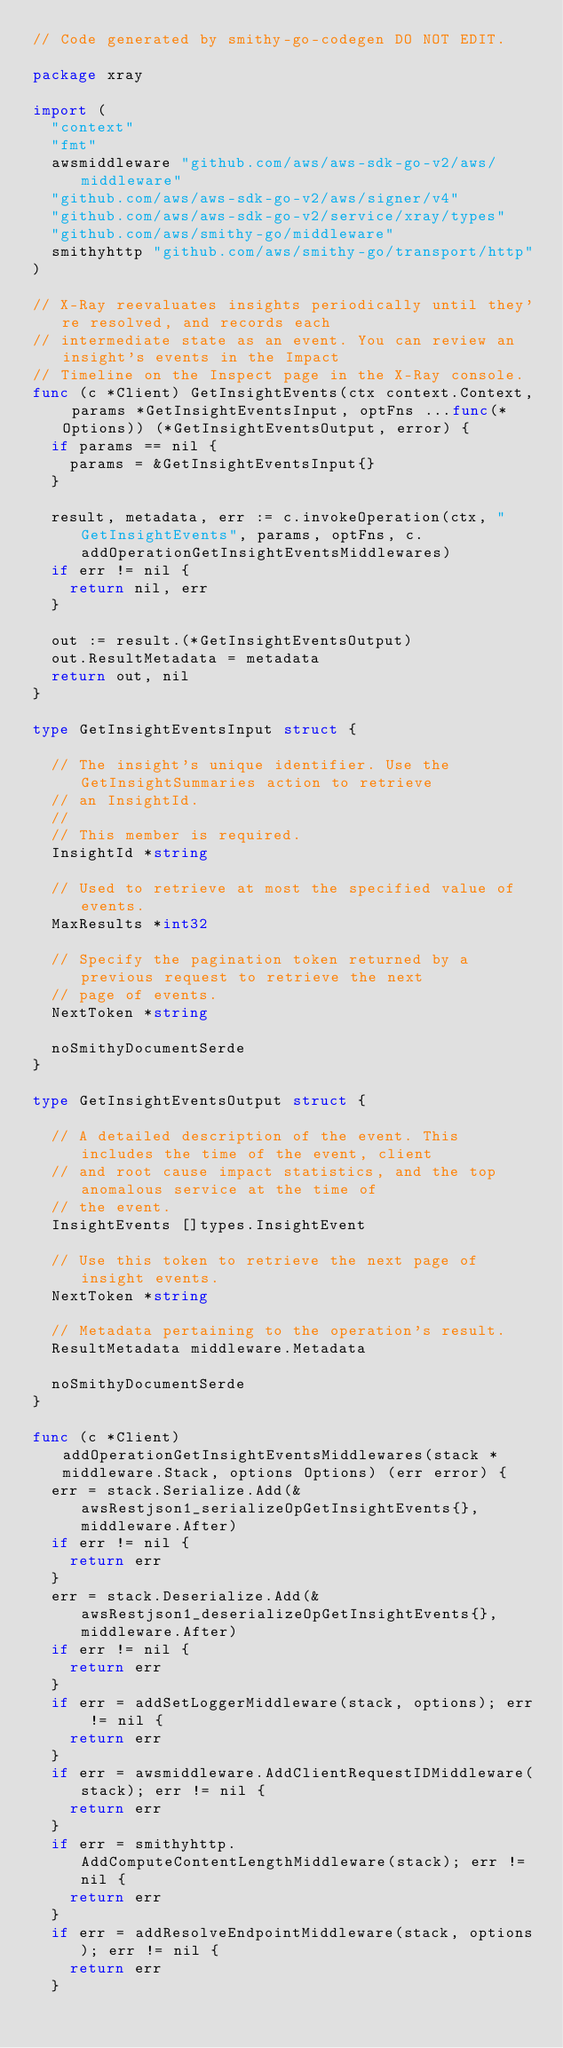Convert code to text. <code><loc_0><loc_0><loc_500><loc_500><_Go_>// Code generated by smithy-go-codegen DO NOT EDIT.

package xray

import (
	"context"
	"fmt"
	awsmiddleware "github.com/aws/aws-sdk-go-v2/aws/middleware"
	"github.com/aws/aws-sdk-go-v2/aws/signer/v4"
	"github.com/aws/aws-sdk-go-v2/service/xray/types"
	"github.com/aws/smithy-go/middleware"
	smithyhttp "github.com/aws/smithy-go/transport/http"
)

// X-Ray reevaluates insights periodically until they're resolved, and records each
// intermediate state as an event. You can review an insight's events in the Impact
// Timeline on the Inspect page in the X-Ray console.
func (c *Client) GetInsightEvents(ctx context.Context, params *GetInsightEventsInput, optFns ...func(*Options)) (*GetInsightEventsOutput, error) {
	if params == nil {
		params = &GetInsightEventsInput{}
	}

	result, metadata, err := c.invokeOperation(ctx, "GetInsightEvents", params, optFns, c.addOperationGetInsightEventsMiddlewares)
	if err != nil {
		return nil, err
	}

	out := result.(*GetInsightEventsOutput)
	out.ResultMetadata = metadata
	return out, nil
}

type GetInsightEventsInput struct {

	// The insight's unique identifier. Use the GetInsightSummaries action to retrieve
	// an InsightId.
	//
	// This member is required.
	InsightId *string

	// Used to retrieve at most the specified value of events.
	MaxResults *int32

	// Specify the pagination token returned by a previous request to retrieve the next
	// page of events.
	NextToken *string

	noSmithyDocumentSerde
}

type GetInsightEventsOutput struct {

	// A detailed description of the event. This includes the time of the event, client
	// and root cause impact statistics, and the top anomalous service at the time of
	// the event.
	InsightEvents []types.InsightEvent

	// Use this token to retrieve the next page of insight events.
	NextToken *string

	// Metadata pertaining to the operation's result.
	ResultMetadata middleware.Metadata

	noSmithyDocumentSerde
}

func (c *Client) addOperationGetInsightEventsMiddlewares(stack *middleware.Stack, options Options) (err error) {
	err = stack.Serialize.Add(&awsRestjson1_serializeOpGetInsightEvents{}, middleware.After)
	if err != nil {
		return err
	}
	err = stack.Deserialize.Add(&awsRestjson1_deserializeOpGetInsightEvents{}, middleware.After)
	if err != nil {
		return err
	}
	if err = addSetLoggerMiddleware(stack, options); err != nil {
		return err
	}
	if err = awsmiddleware.AddClientRequestIDMiddleware(stack); err != nil {
		return err
	}
	if err = smithyhttp.AddComputeContentLengthMiddleware(stack); err != nil {
		return err
	}
	if err = addResolveEndpointMiddleware(stack, options); err != nil {
		return err
	}</code> 